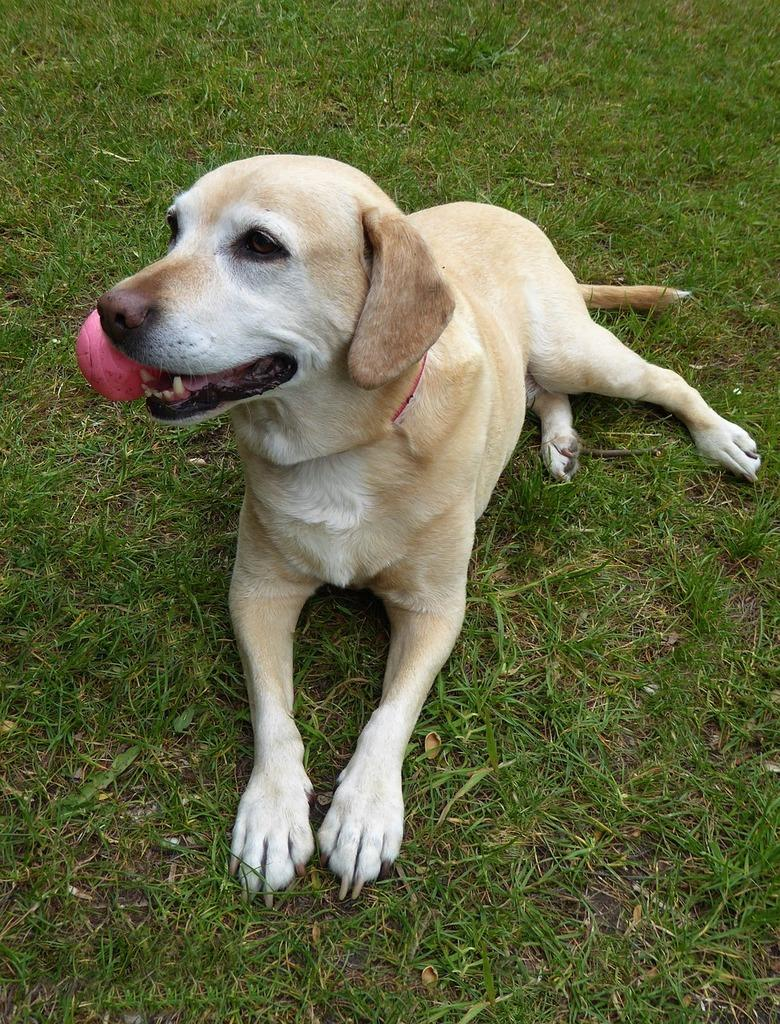What type of animal is present in the image? There is a dog in the image. What can be seen in the background of the image? There is grass in the background of the image. What design is featured on the dog's collar in the image? There is no collar visible on the dog in the image, so it is not possible to determine the design. 